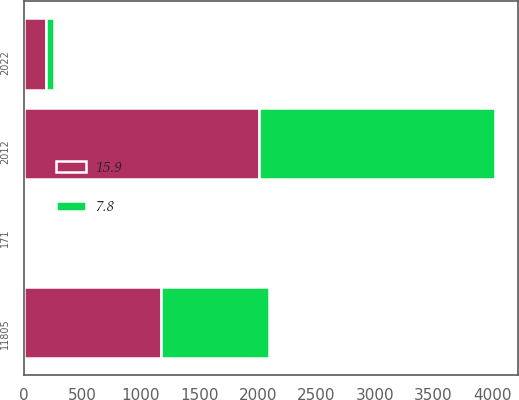Convert chart. <chart><loc_0><loc_0><loc_500><loc_500><stacked_bar_chart><ecel><fcel>2012<fcel>11805<fcel>2022<fcel>171<nl><fcel>15.9<fcel>2011<fcel>1177.6<fcel>187.6<fcel>15.9<nl><fcel>7.8<fcel>2010<fcel>917<fcel>71.1<fcel>7.8<nl></chart> 